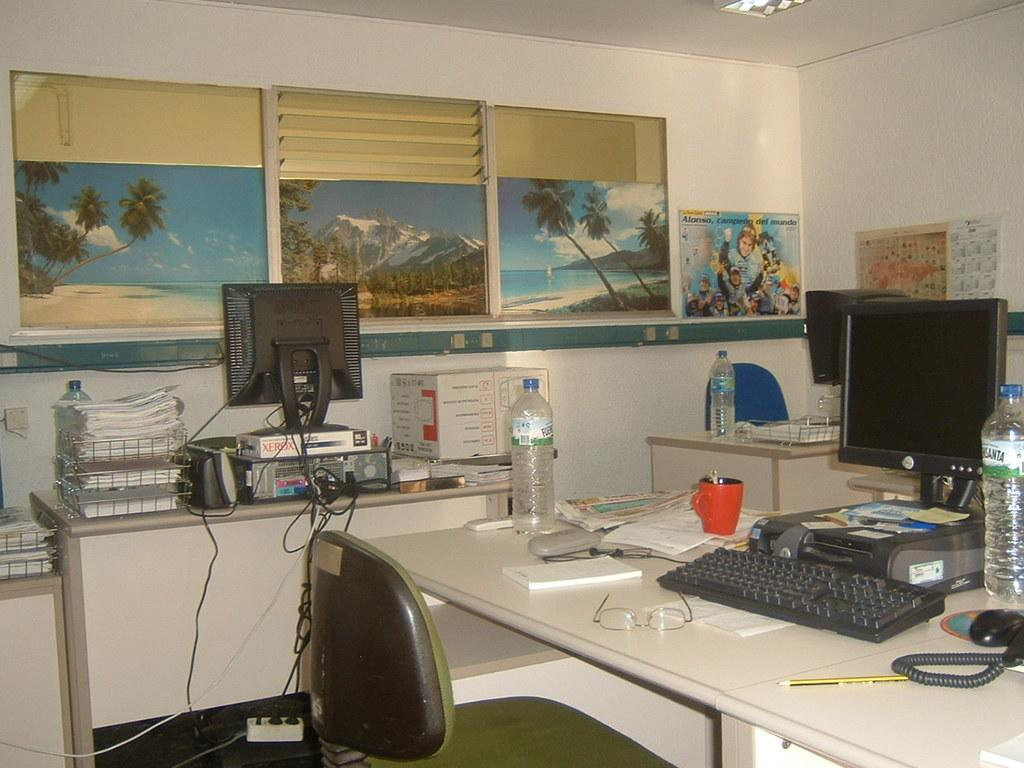<image>
Relay a brief, clear account of the picture shown. Package with a Xerox logo near a Dell computer. 